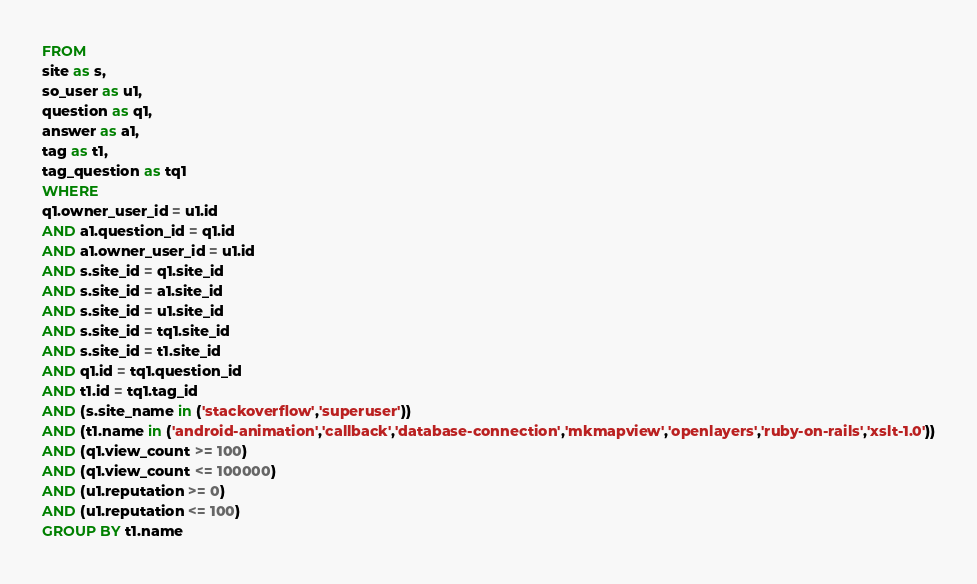<code> <loc_0><loc_0><loc_500><loc_500><_SQL_>FROM
site as s,
so_user as u1,
question as q1,
answer as a1,
tag as t1,
tag_question as tq1
WHERE
q1.owner_user_id = u1.id
AND a1.question_id = q1.id
AND a1.owner_user_id = u1.id
AND s.site_id = q1.site_id
AND s.site_id = a1.site_id
AND s.site_id = u1.site_id
AND s.site_id = tq1.site_id
AND s.site_id = t1.site_id
AND q1.id = tq1.question_id
AND t1.id = tq1.tag_id
AND (s.site_name in ('stackoverflow','superuser'))
AND (t1.name in ('android-animation','callback','database-connection','mkmapview','openlayers','ruby-on-rails','xslt-1.0'))
AND (q1.view_count >= 100)
AND (q1.view_count <= 100000)
AND (u1.reputation >= 0)
AND (u1.reputation <= 100)
GROUP BY t1.name</code> 